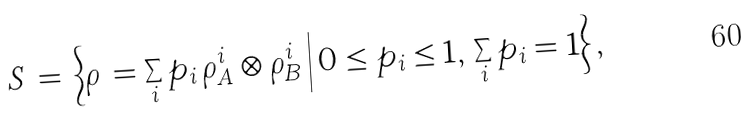<formula> <loc_0><loc_0><loc_500><loc_500>S \, = \, \Big \{ \rho \, = \sum _ { i } p _ { i } \, \rho _ { A } ^ { i } \otimes \rho _ { B } ^ { i } \, \Big | \, 0 \leq p _ { i } \leq 1 , \, \sum _ { i } p _ { i } = 1 \Big \} \, ,</formula> 